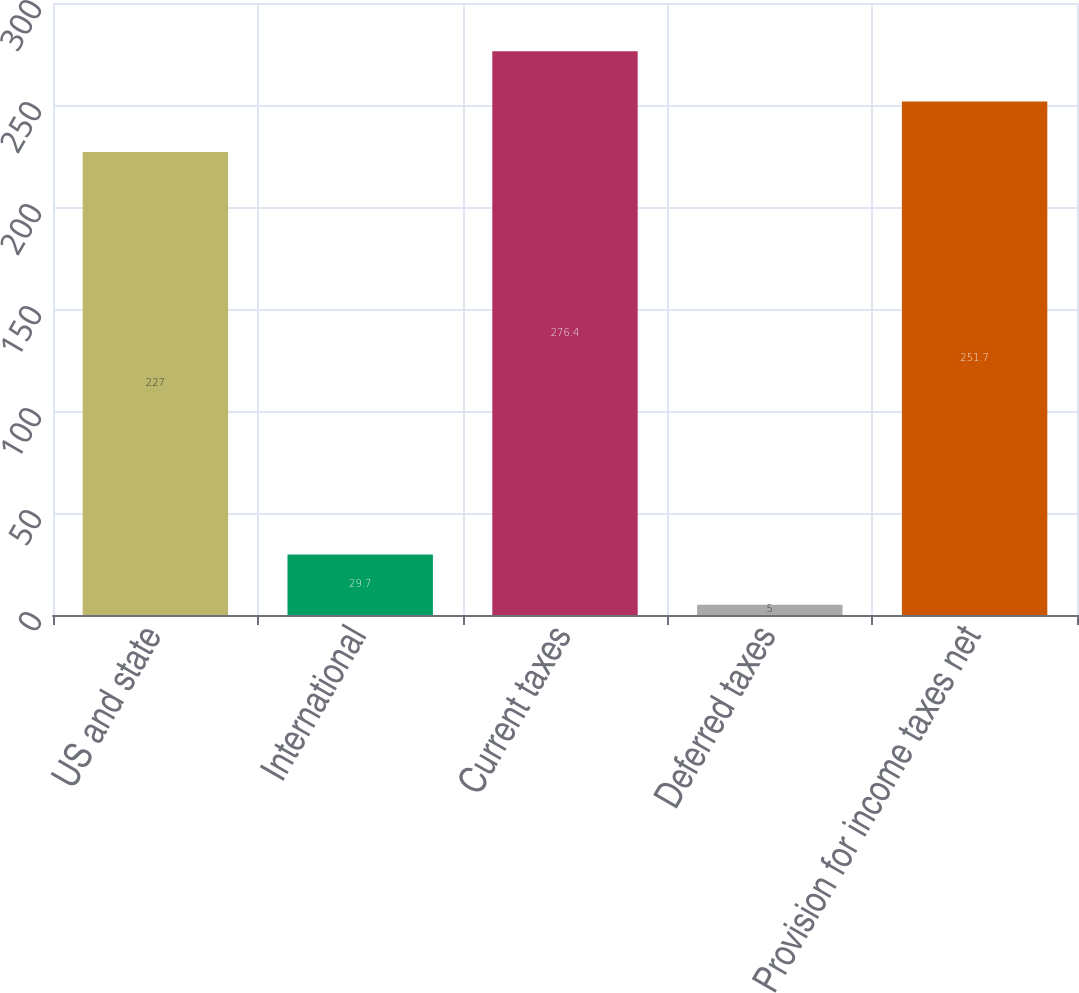Convert chart. <chart><loc_0><loc_0><loc_500><loc_500><bar_chart><fcel>US and state<fcel>International<fcel>Current taxes<fcel>Deferred taxes<fcel>Provision for income taxes net<nl><fcel>227<fcel>29.7<fcel>276.4<fcel>5<fcel>251.7<nl></chart> 